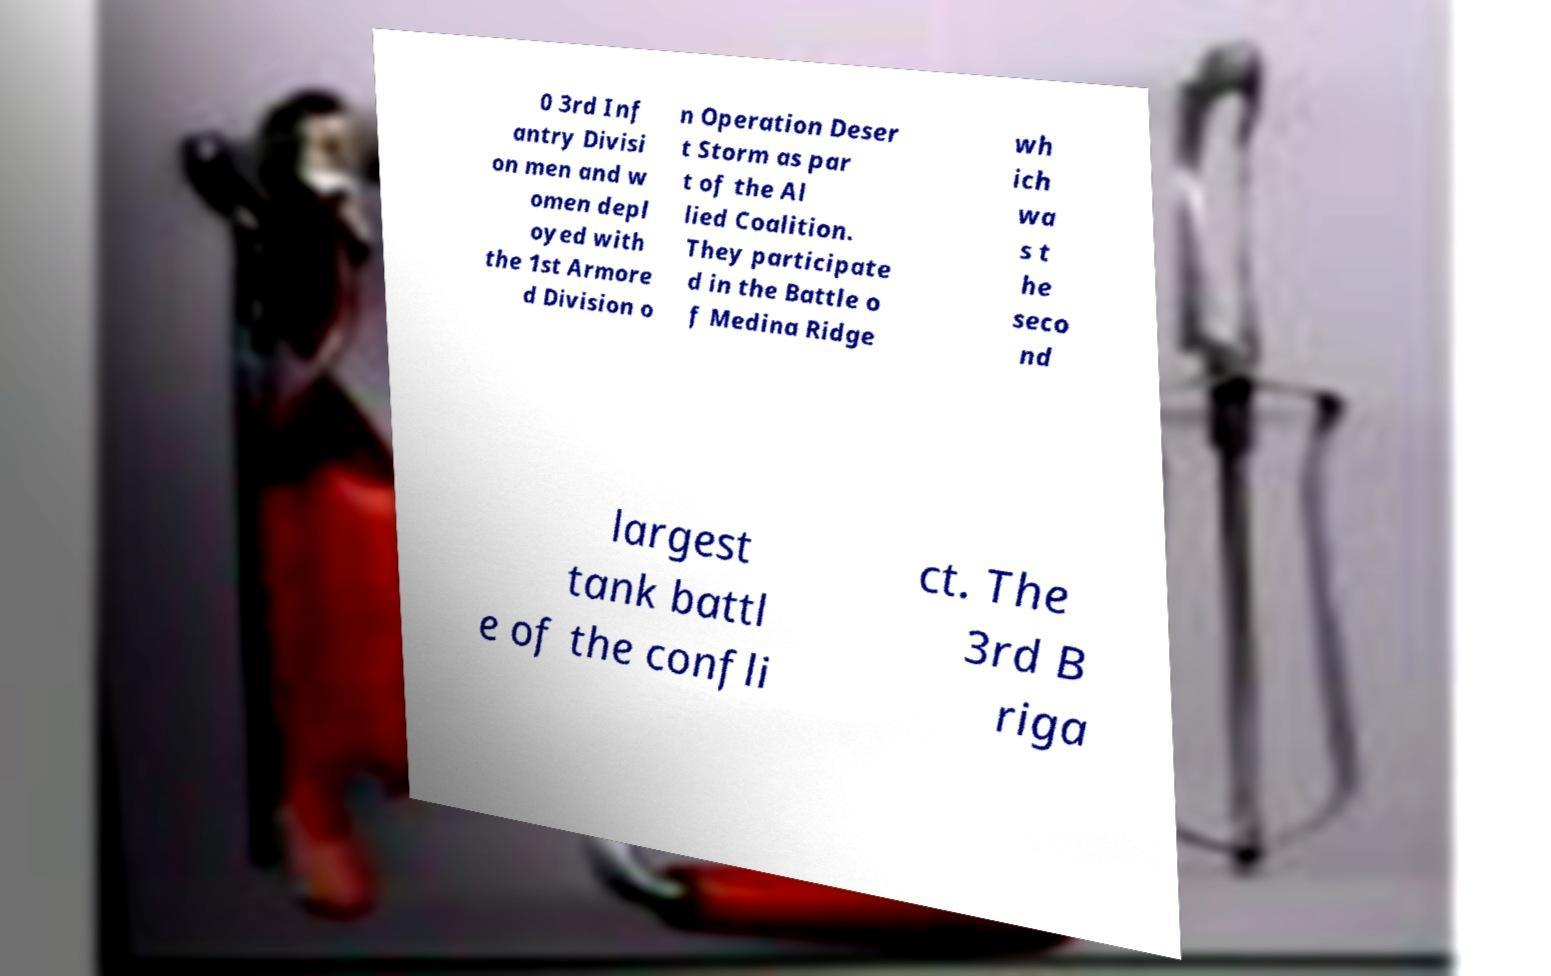Can you accurately transcribe the text from the provided image for me? 0 3rd Inf antry Divisi on men and w omen depl oyed with the 1st Armore d Division o n Operation Deser t Storm as par t of the Al lied Coalition. They participate d in the Battle o f Medina Ridge wh ich wa s t he seco nd largest tank battl e of the confli ct. The 3rd B riga 